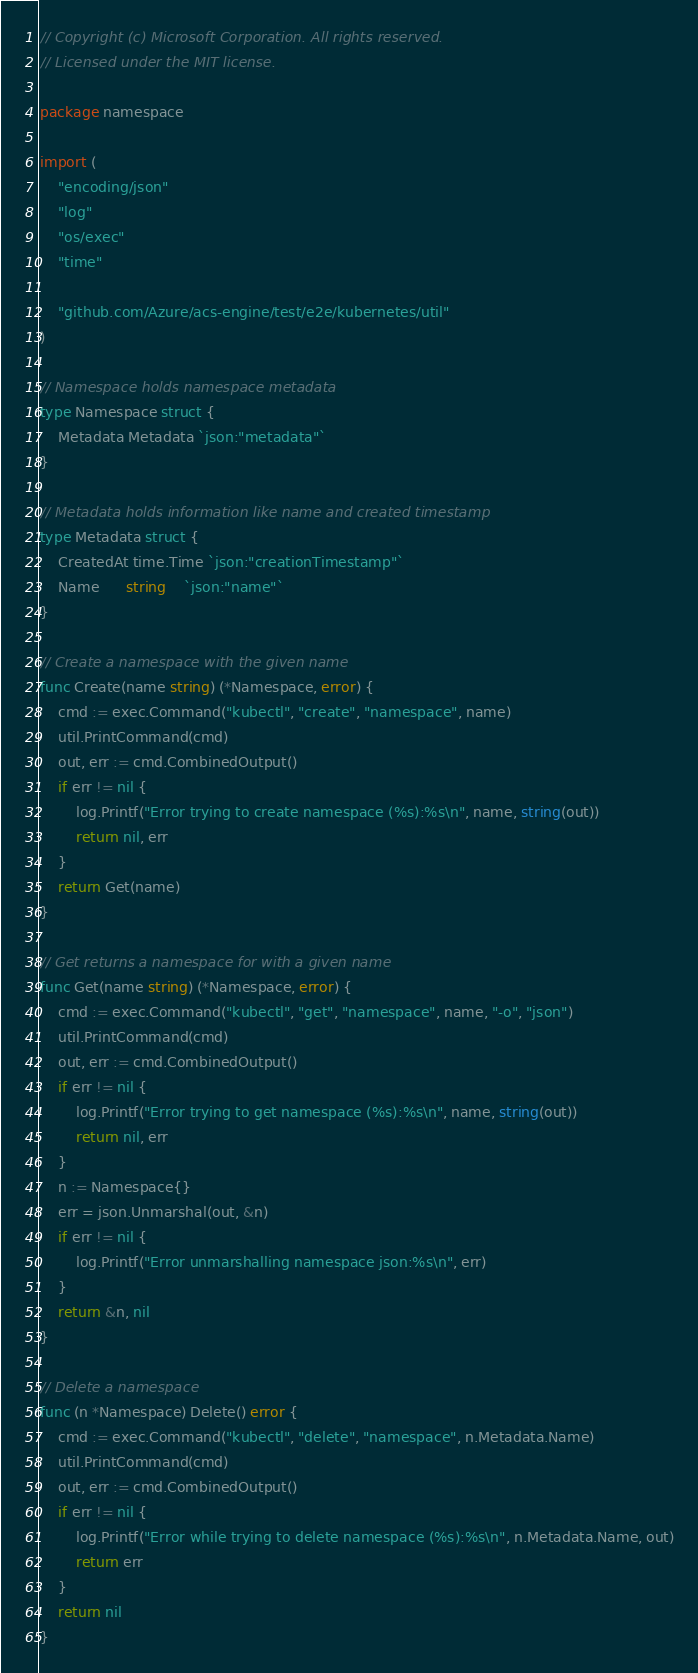Convert code to text. <code><loc_0><loc_0><loc_500><loc_500><_Go_>// Copyright (c) Microsoft Corporation. All rights reserved.
// Licensed under the MIT license.

package namespace

import (
	"encoding/json"
	"log"
	"os/exec"
	"time"

	"github.com/Azure/acs-engine/test/e2e/kubernetes/util"
)

// Namespace holds namespace metadata
type Namespace struct {
	Metadata Metadata `json:"metadata"`
}

// Metadata holds information like name and created timestamp
type Metadata struct {
	CreatedAt time.Time `json:"creationTimestamp"`
	Name      string    `json:"name"`
}

// Create a namespace with the given name
func Create(name string) (*Namespace, error) {
	cmd := exec.Command("kubectl", "create", "namespace", name)
	util.PrintCommand(cmd)
	out, err := cmd.CombinedOutput()
	if err != nil {
		log.Printf("Error trying to create namespace (%s):%s\n", name, string(out))
		return nil, err
	}
	return Get(name)
}

// Get returns a namespace for with a given name
func Get(name string) (*Namespace, error) {
	cmd := exec.Command("kubectl", "get", "namespace", name, "-o", "json")
	util.PrintCommand(cmd)
	out, err := cmd.CombinedOutput()
	if err != nil {
		log.Printf("Error trying to get namespace (%s):%s\n", name, string(out))
		return nil, err
	}
	n := Namespace{}
	err = json.Unmarshal(out, &n)
	if err != nil {
		log.Printf("Error unmarshalling namespace json:%s\n", err)
	}
	return &n, nil
}

// Delete a namespace
func (n *Namespace) Delete() error {
	cmd := exec.Command("kubectl", "delete", "namespace", n.Metadata.Name)
	util.PrintCommand(cmd)
	out, err := cmd.CombinedOutput()
	if err != nil {
		log.Printf("Error while trying to delete namespace (%s):%s\n", n.Metadata.Name, out)
		return err
	}
	return nil
}
</code> 